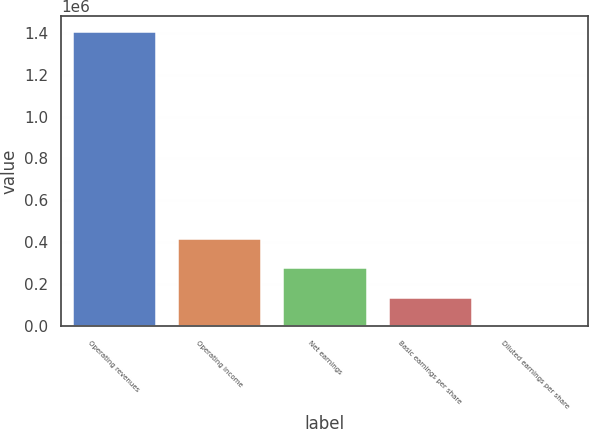<chart> <loc_0><loc_0><loc_500><loc_500><bar_chart><fcel>Operating revenues<fcel>Operating income<fcel>Net earnings<fcel>Basic earnings per share<fcel>Diluted earnings per share<nl><fcel>1.40691e+06<fcel>422073<fcel>281382<fcel>140691<fcel>0.58<nl></chart> 